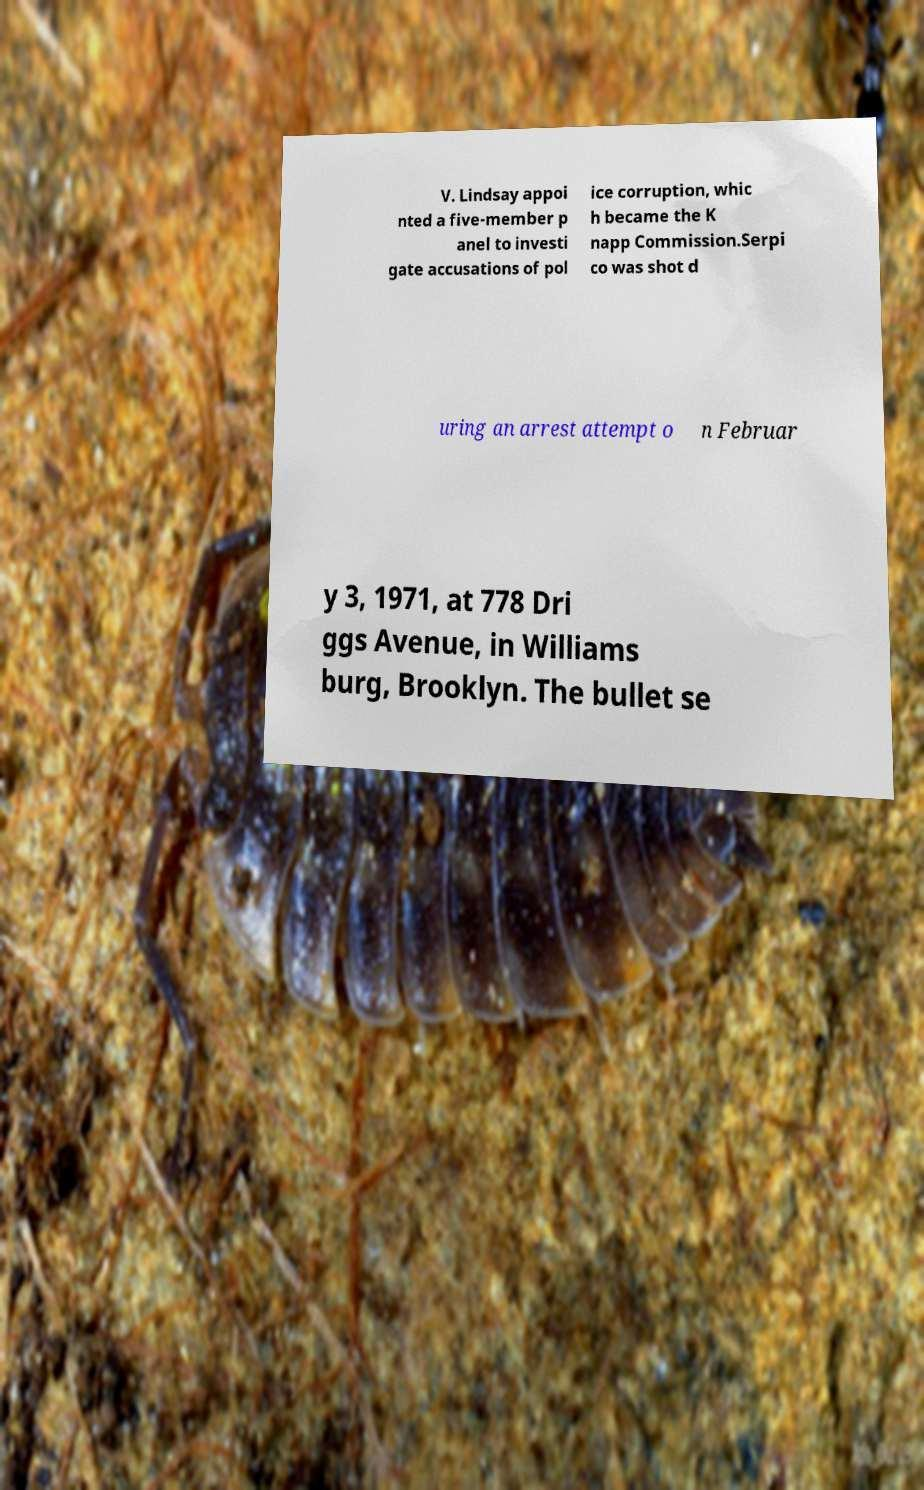Can you accurately transcribe the text from the provided image for me? V. Lindsay appoi nted a five-member p anel to investi gate accusations of pol ice corruption, whic h became the K napp Commission.Serpi co was shot d uring an arrest attempt o n Februar y 3, 1971, at 778 Dri ggs Avenue, in Williams burg, Brooklyn. The bullet se 